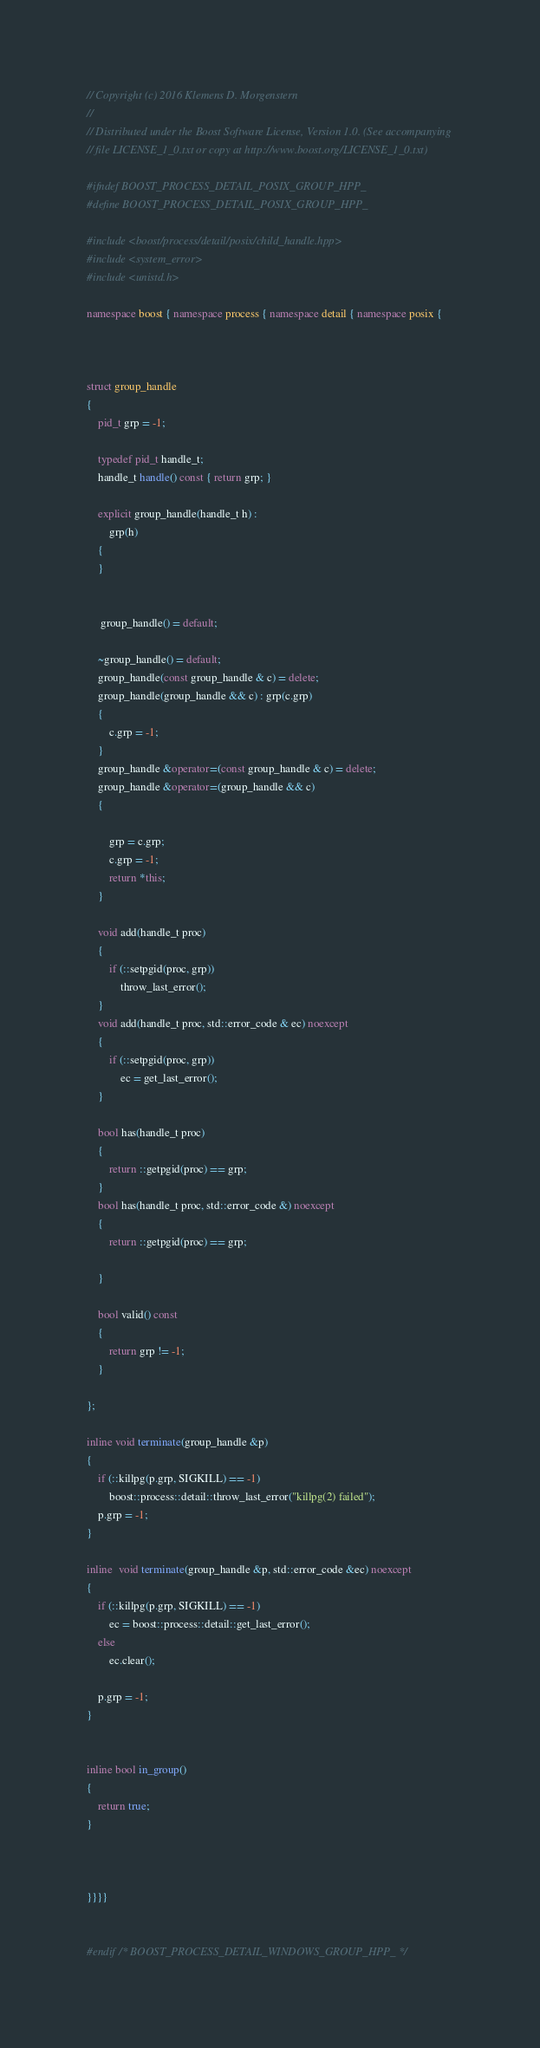Convert code to text. <code><loc_0><loc_0><loc_500><loc_500><_C++_>// Copyright (c) 2016 Klemens D. Morgenstern
//
// Distributed under the Boost Software License, Version 1.0. (See accompanying
// file LICENSE_1_0.txt or copy at http://www.boost.org/LICENSE_1_0.txt)

#ifndef BOOST_PROCESS_DETAIL_POSIX_GROUP_HPP_
#define BOOST_PROCESS_DETAIL_POSIX_GROUP_HPP_

#include <boost/process/detail/posix/child_handle.hpp>
#include <system_error>
#include <unistd.h>

namespace boost { namespace process { namespace detail { namespace posix {



struct group_handle
{
    pid_t grp = -1;

    typedef pid_t handle_t;
    handle_t handle() const { return grp; }

    explicit group_handle(handle_t h) :
        grp(h)
    {
    }


     group_handle() = default;

    ~group_handle() = default;
    group_handle(const group_handle & c) = delete;
    group_handle(group_handle && c) : grp(c.grp)
    {
        c.grp = -1;
    }
    group_handle &operator=(const group_handle & c) = delete;
    group_handle &operator=(group_handle && c)
    {

        grp = c.grp;
        c.grp = -1;
        return *this;
    }

    void add(handle_t proc)
    {   
        if (::setpgid(proc, grp))
            throw_last_error();
    }
    void add(handle_t proc, std::error_code & ec) noexcept
    {
        if (::setpgid(proc, grp))
            ec = get_last_error();
    }

    bool has(handle_t proc)
    {
        return ::getpgid(proc) == grp;
    }
    bool has(handle_t proc, std::error_code &) noexcept
    {
        return ::getpgid(proc) == grp;

    }

    bool valid() const
    {
        return grp != -1;
    }

};

inline void terminate(group_handle &p)
{
    if (::killpg(p.grp, SIGKILL) == -1)
        boost::process::detail::throw_last_error("killpg(2) failed");
    p.grp = -1;
}

inline  void terminate(group_handle &p, std::error_code &ec) noexcept
{
    if (::killpg(p.grp, SIGKILL) == -1)
        ec = boost::process::detail::get_last_error();
    else
        ec.clear();

    p.grp = -1;
}


inline bool in_group()
{
    return true;
}



}}}}


#endif /* BOOST_PROCESS_DETAIL_WINDOWS_GROUP_HPP_ */
</code> 